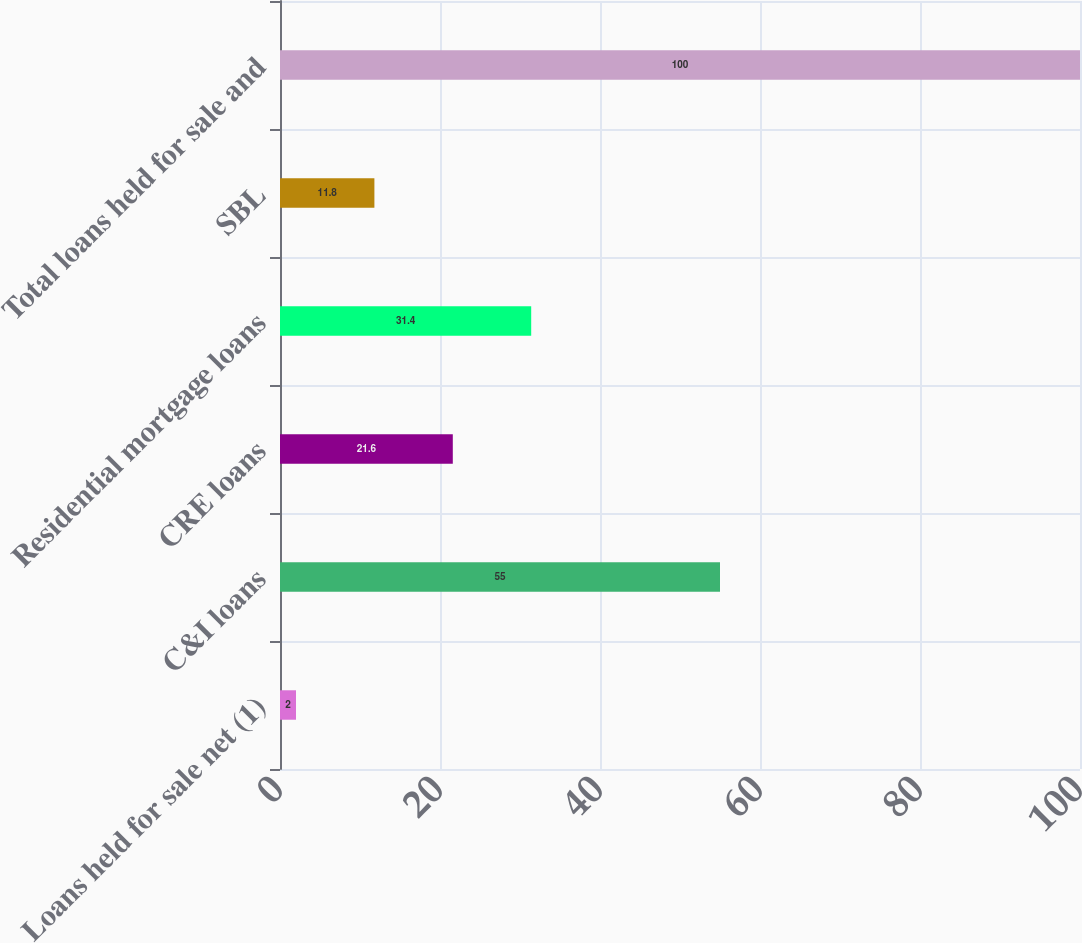Convert chart to OTSL. <chart><loc_0><loc_0><loc_500><loc_500><bar_chart><fcel>Loans held for sale net (1)<fcel>C&I loans<fcel>CRE loans<fcel>Residential mortgage loans<fcel>SBL<fcel>Total loans held for sale and<nl><fcel>2<fcel>55<fcel>21.6<fcel>31.4<fcel>11.8<fcel>100<nl></chart> 